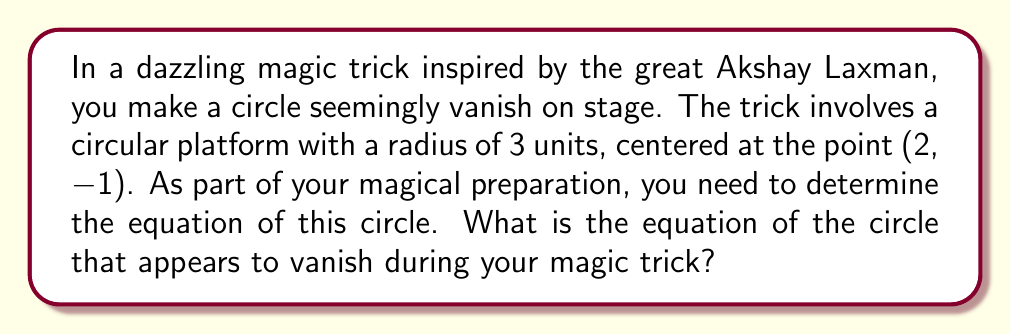Help me with this question. To find the equation of the circle, we'll use the general form of a circle equation:

$$(x - h)^2 + (y - k)^2 = r^2$$

Where $(h, k)$ is the center of the circle and $r$ is the radius.

Given information:
- Center of the circle: (2, -1)
- Radius: 3 units

Let's plug these values into the equation:

1. Center coordinates:
   $h = 2$
   $k = -1$

2. Radius:
   $r = 3$

Now, let's substitute these values into the general equation:

$$(x - 2)^2 + (y - (-1))^2 = 3^2$$

Simplify:

$$(x - 2)^2 + (y + 1)^2 = 9$$

This is the equation of the circle that appears to vanish during the magic trick.

[asy]
import geometry;

size(200);
pair center = (2,-1);
real radius = 3;

draw(circle(center, radius), black+1);
dot(center, red);
label("(2, -1)", center, NE);

xaxis(-2, 6, arrow=Arrow);
yaxis(-5, 3, arrow=Arrow);

label("x", (6,0), E);
label("y", (0,3), N);
[/asy]
Answer: $(x - 2)^2 + (y + 1)^2 = 9$ 